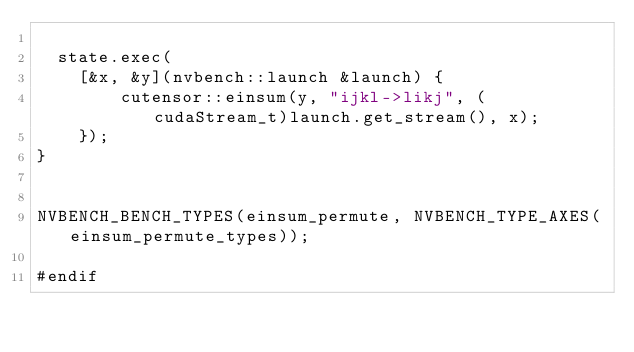Convert code to text. <code><loc_0><loc_0><loc_500><loc_500><_Cuda_>
  state.exec( 
    [&x, &y](nvbench::launch &launch) {
        cutensor::einsum(y, "ijkl->likj", (cudaStream_t)launch.get_stream(), x);
    });
}


NVBENCH_BENCH_TYPES(einsum_permute, NVBENCH_TYPE_AXES(einsum_permute_types));

#endif
</code> 